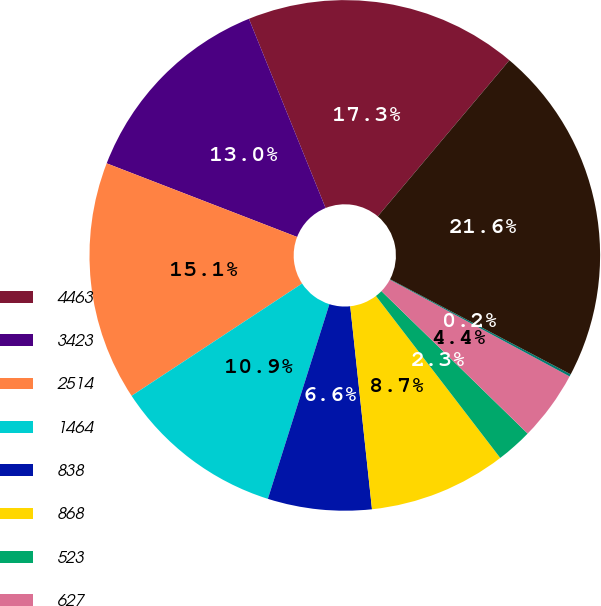Convert chart to OTSL. <chart><loc_0><loc_0><loc_500><loc_500><pie_chart><fcel>4463<fcel>3423<fcel>2514<fcel>1464<fcel>838<fcel>868<fcel>523<fcel>627<fcel>416<fcel>15136<nl><fcel>17.28%<fcel>13.0%<fcel>15.14%<fcel>10.86%<fcel>6.57%<fcel>8.72%<fcel>2.29%<fcel>4.43%<fcel>0.15%<fcel>21.56%<nl></chart> 